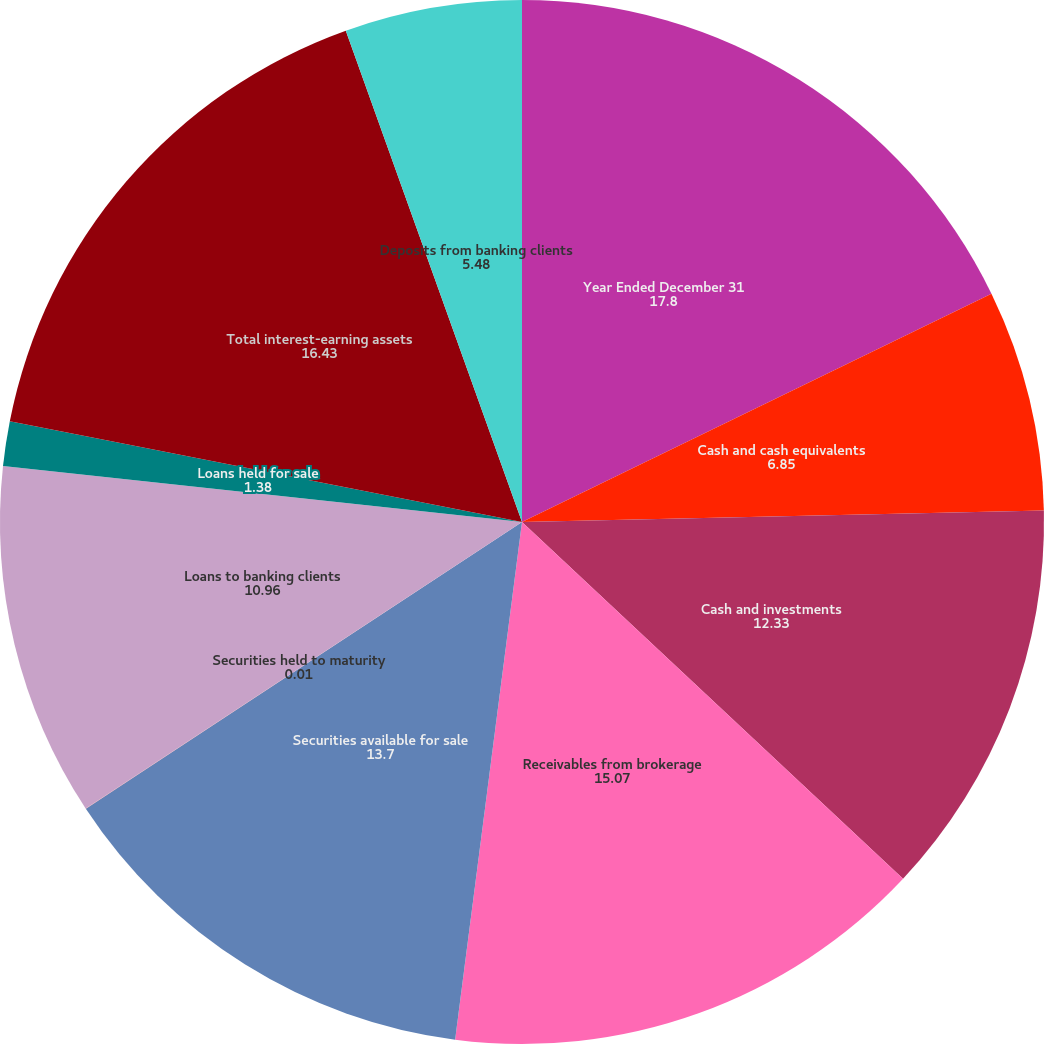<chart> <loc_0><loc_0><loc_500><loc_500><pie_chart><fcel>Year Ended December 31<fcel>Cash and cash equivalents<fcel>Cash and investments<fcel>Receivables from brokerage<fcel>Securities available for sale<fcel>Securities held to maturity<fcel>Loans to banking clients<fcel>Loans held for sale<fcel>Total interest-earning assets<fcel>Deposits from banking clients<nl><fcel>17.8%<fcel>6.85%<fcel>12.33%<fcel>15.07%<fcel>13.7%<fcel>0.01%<fcel>10.96%<fcel>1.38%<fcel>16.43%<fcel>5.48%<nl></chart> 